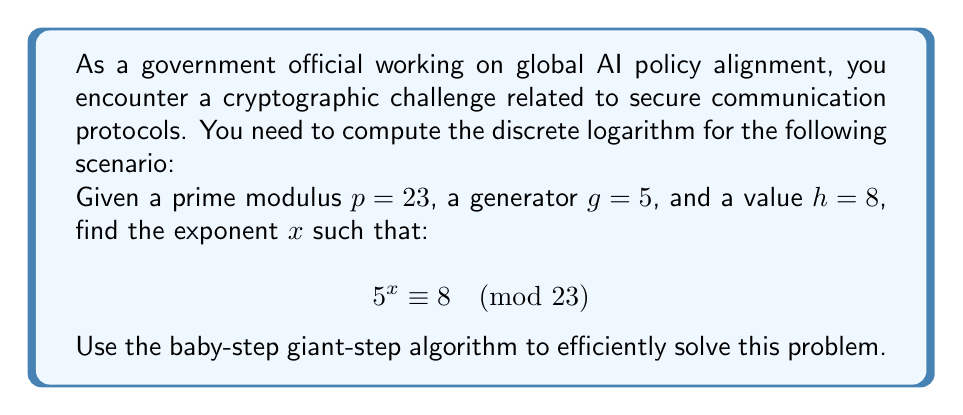Can you solve this math problem? To solve this discrete logarithm problem using the baby-step giant-step algorithm, we follow these steps:

1) First, calculate $m = \lceil\sqrt{p-1}\rceil = \lceil\sqrt{22}\rceil = 5$

2) Create two lists:
   
   Baby-step list: $\{g^j \bmod p : 0 \leq j < m\}$
   Giant-step list: $\{h \cdot g^{-im} \bmod p : 0 \leq i < m\}$

3) Baby-step list calculation:
   $5^0 \equiv 1 \pmod{23}$
   $5^1 \equiv 5 \pmod{23}$
   $5^2 \equiv 2 \pmod{23}$
   $5^3 \equiv 10 \pmod{23}$
   $5^4 \equiv 4 \pmod{23}$

4) For the giant-step list, we need $g^{-m} \bmod p$:
   $5^{-5} \equiv 5^{18} \equiv 16 \pmod{23}$ (using Fermat's Little Theorem)

5) Giant-step list calculation:
   $8 \cdot 16^0 \equiv 8 \pmod{23}$
   $8 \cdot 16^1 \equiv 13 \pmod{23}$
   $8 \cdot 16^2 \equiv 23 \equiv 0 \pmod{23}$
   $8 \cdot 16^3 \equiv 0 \pmod{23}$
   $8 \cdot 16^4 \equiv 0 \pmod{23}$

6) We find a match: $5^2 \equiv 2 \pmod{23}$ and $8 \cdot 16^1 \equiv 13 \pmod{23}$

7) Therefore, $x = 2 + 1 \cdot 5 = 7$

8) Verify: $5^7 \equiv 8 \pmod{23}$
Answer: $x = 7$ 